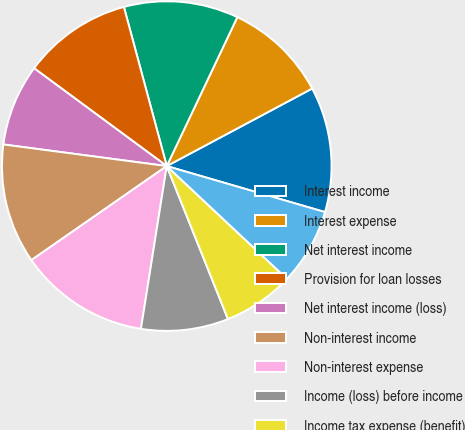Convert chart to OTSL. <chart><loc_0><loc_0><loc_500><loc_500><pie_chart><fcel>Interest income<fcel>Interest expense<fcel>Net interest income<fcel>Provision for loan losses<fcel>Net interest income (loss)<fcel>Non-interest income<fcel>Non-interest expense<fcel>Income (loss) before income<fcel>Income tax expense (benefit)<fcel>Income (loss) from continuing<nl><fcel>12.3%<fcel>10.16%<fcel>11.23%<fcel>10.7%<fcel>8.02%<fcel>11.76%<fcel>12.83%<fcel>8.56%<fcel>6.95%<fcel>7.49%<nl></chart> 